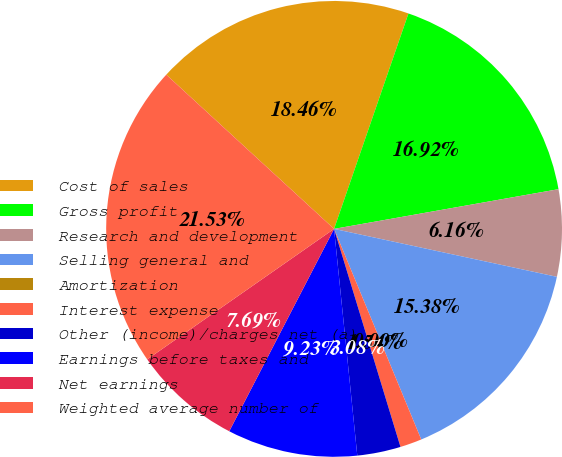Convert chart. <chart><loc_0><loc_0><loc_500><loc_500><pie_chart><fcel>Cost of sales<fcel>Gross profit<fcel>Research and development<fcel>Selling general and<fcel>Amortization<fcel>Interest expense<fcel>Other (income)/charges net (a)<fcel>Earnings before taxes and<fcel>Net earnings<fcel>Weighted average number of<nl><fcel>18.46%<fcel>16.92%<fcel>6.16%<fcel>15.38%<fcel>0.0%<fcel>1.54%<fcel>3.08%<fcel>9.23%<fcel>7.69%<fcel>21.53%<nl></chart> 